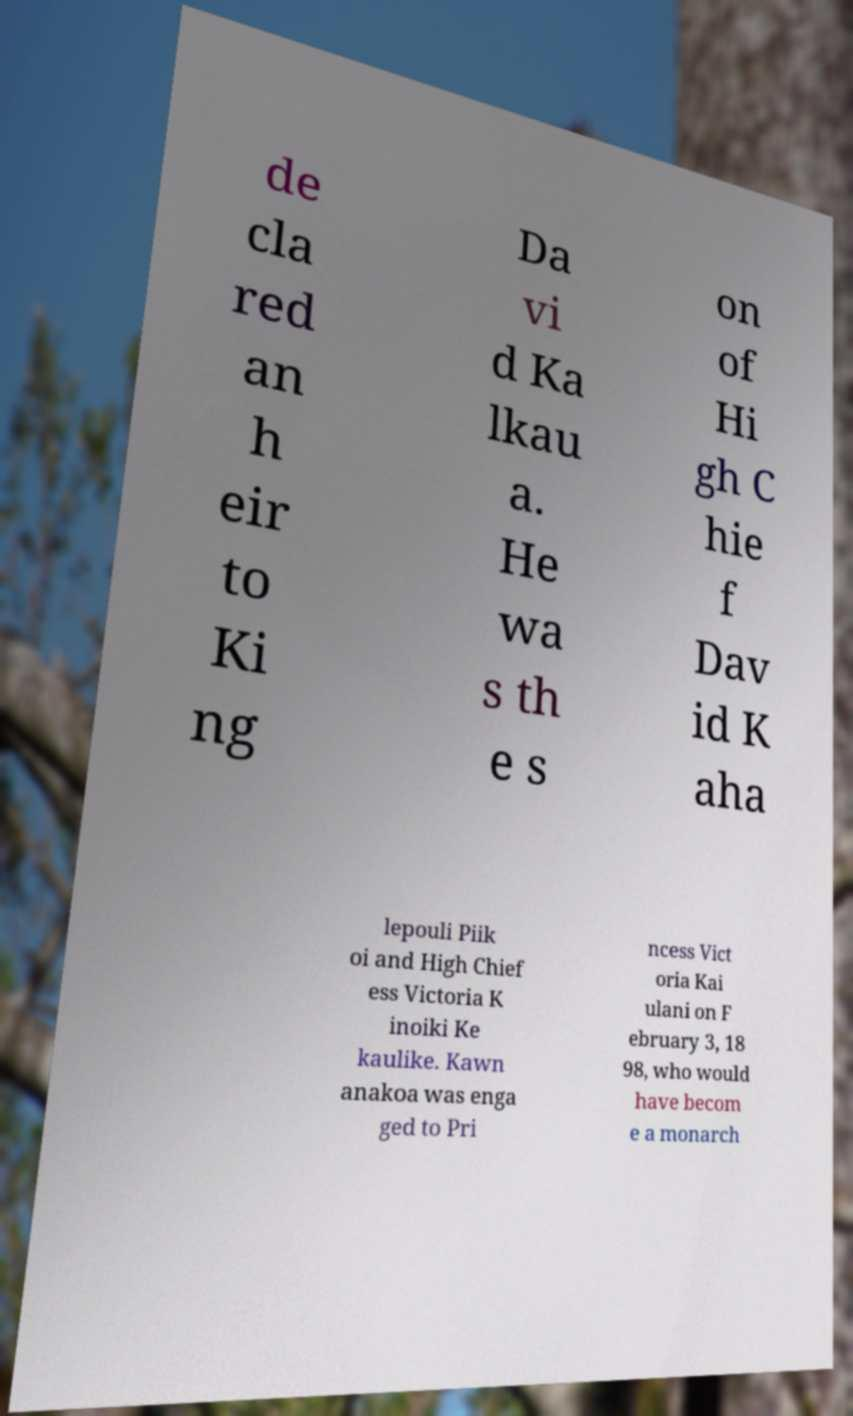Please read and relay the text visible in this image. What does it say? de cla red an h eir to Ki ng Da vi d Ka lkau a. He wa s th e s on of Hi gh C hie f Dav id K aha lepouli Piik oi and High Chief ess Victoria K inoiki Ke kaulike. Kawn anakoa was enga ged to Pri ncess Vict oria Kai ulani on F ebruary 3, 18 98, who would have becom e a monarch 